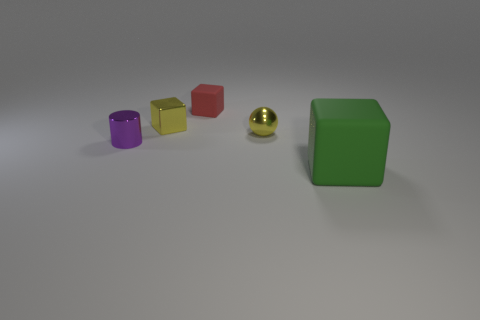The cube that is on the left side of the rubber block behind the purple thing is made of what material?
Ensure brevity in your answer.  Metal. Are there fewer red things behind the large rubber object than yellow blocks?
Give a very brief answer. No. What is the shape of the small yellow thing behind the yellow shiny ball?
Provide a short and direct response. Cube. There is a red rubber cube; does it have the same size as the block that is in front of the purple cylinder?
Your answer should be compact. No. Is there a big red ball made of the same material as the small purple object?
Make the answer very short. No. What number of spheres are big green metal things or tiny objects?
Provide a short and direct response. 1. There is a tiny cube in front of the red rubber block; are there any tiny metallic balls behind it?
Your response must be concise. No. Is the number of big yellow rubber balls less than the number of spheres?
Your answer should be compact. Yes. What number of other yellow objects have the same shape as the tiny rubber object?
Offer a very short reply. 1. How many purple things are metal things or big things?
Your response must be concise. 1. 